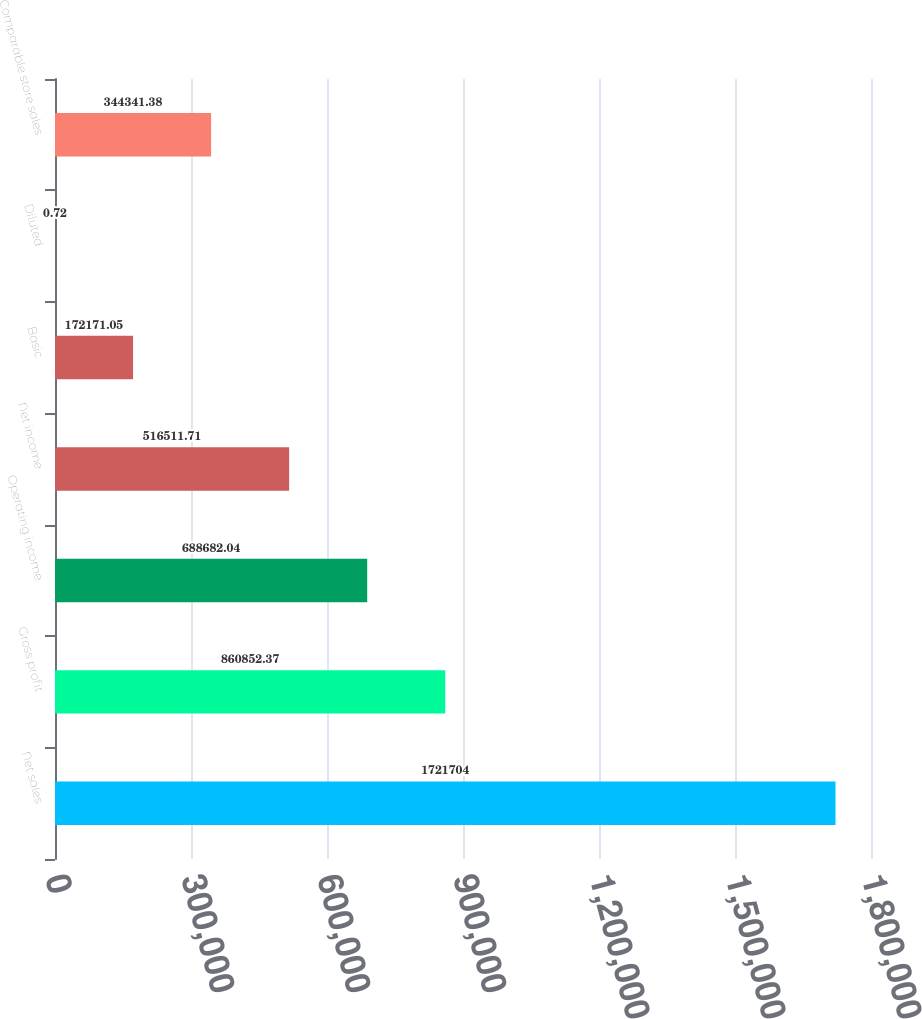Convert chart to OTSL. <chart><loc_0><loc_0><loc_500><loc_500><bar_chart><fcel>Net sales<fcel>Gross profit<fcel>Operating income<fcel>Net income<fcel>Basic<fcel>Diluted<fcel>Comparable store sales<nl><fcel>1.7217e+06<fcel>860852<fcel>688682<fcel>516512<fcel>172171<fcel>0.72<fcel>344341<nl></chart> 